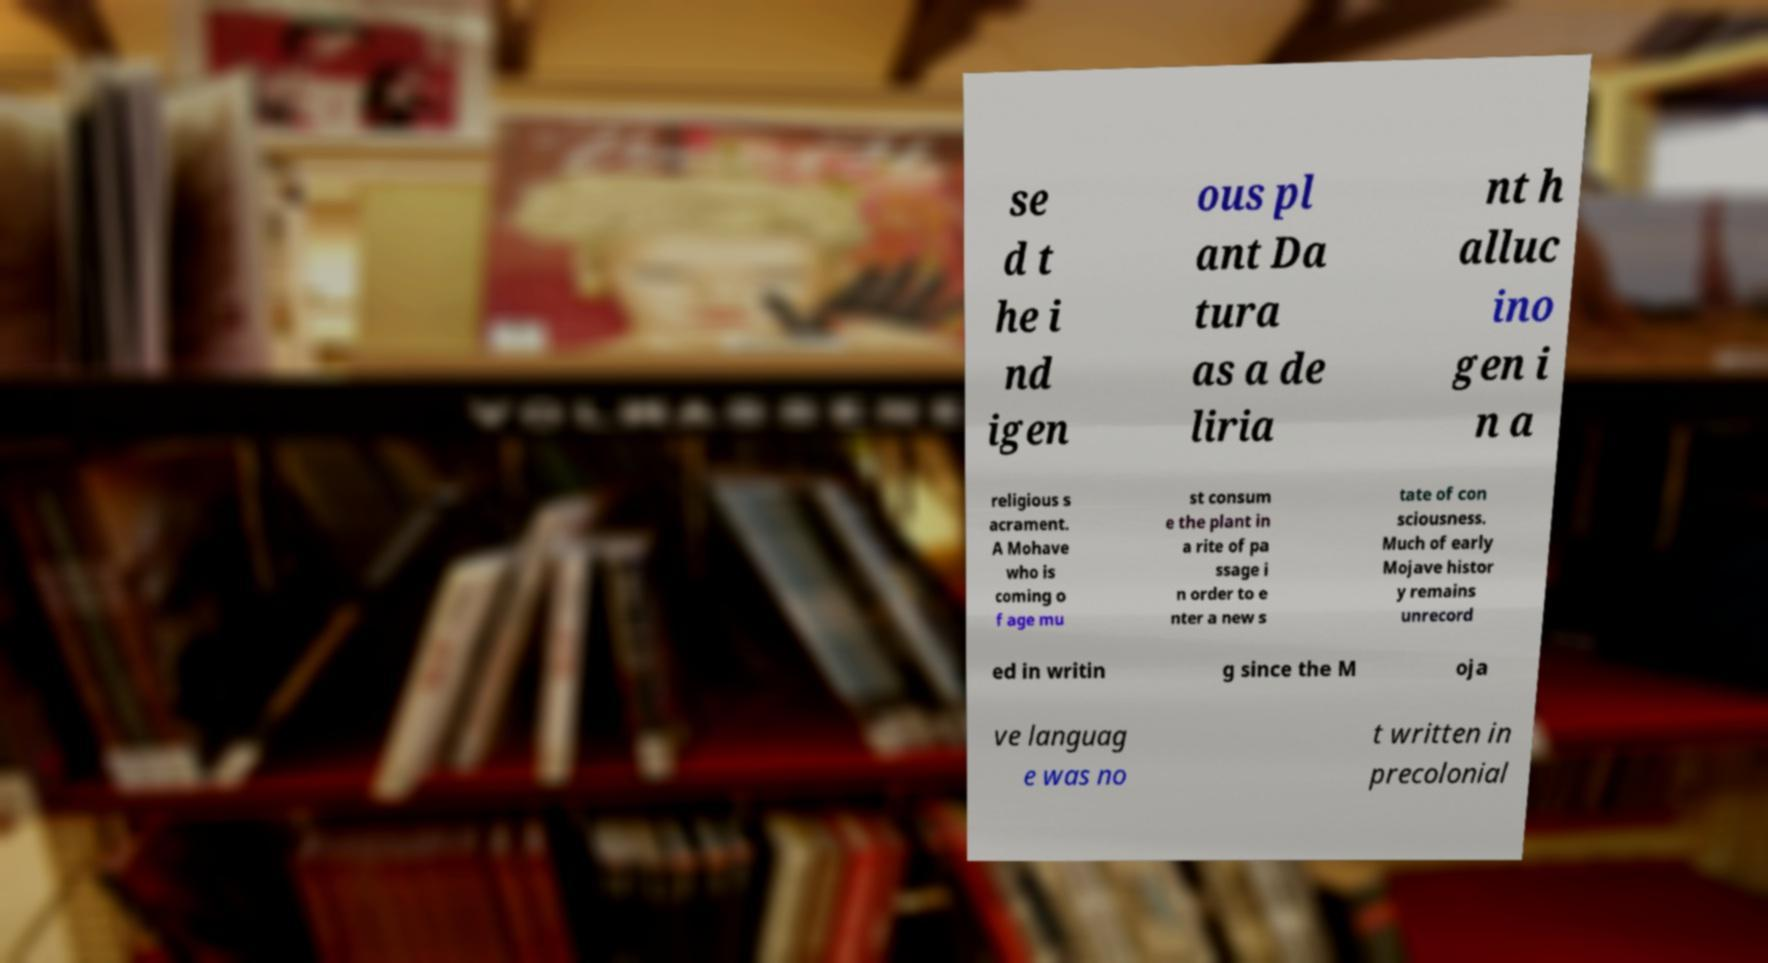What messages or text are displayed in this image? I need them in a readable, typed format. se d t he i nd igen ous pl ant Da tura as a de liria nt h alluc ino gen i n a religious s acrament. A Mohave who is coming o f age mu st consum e the plant in a rite of pa ssage i n order to e nter a new s tate of con sciousness. Much of early Mojave histor y remains unrecord ed in writin g since the M oja ve languag e was no t written in precolonial 